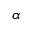<formula> <loc_0><loc_0><loc_500><loc_500>\alpha</formula> 